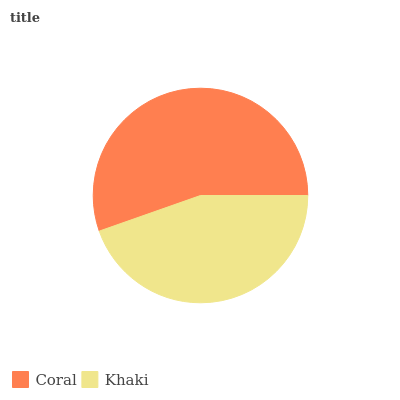Is Khaki the minimum?
Answer yes or no. Yes. Is Coral the maximum?
Answer yes or no. Yes. Is Khaki the maximum?
Answer yes or no. No. Is Coral greater than Khaki?
Answer yes or no. Yes. Is Khaki less than Coral?
Answer yes or no. Yes. Is Khaki greater than Coral?
Answer yes or no. No. Is Coral less than Khaki?
Answer yes or no. No. Is Coral the high median?
Answer yes or no. Yes. Is Khaki the low median?
Answer yes or no. Yes. Is Khaki the high median?
Answer yes or no. No. Is Coral the low median?
Answer yes or no. No. 